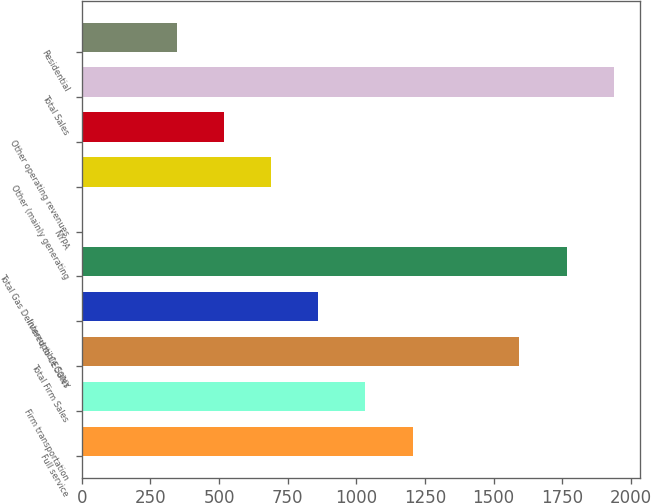<chart> <loc_0><loc_0><loc_500><loc_500><bar_chart><fcel>Full service<fcel>Firm transportation<fcel>Total Firm Sales<fcel>Interruptible Sales<fcel>Total Gas Delivered to CECONY<fcel>NYPA<fcel>Other (mainly generating<fcel>Other operating revenues<fcel>Total Sales<fcel>Residential<nl><fcel>1205.3<fcel>1033.4<fcel>1594<fcel>861.5<fcel>1765.9<fcel>2<fcel>689.6<fcel>517.7<fcel>1937.8<fcel>345.8<nl></chart> 